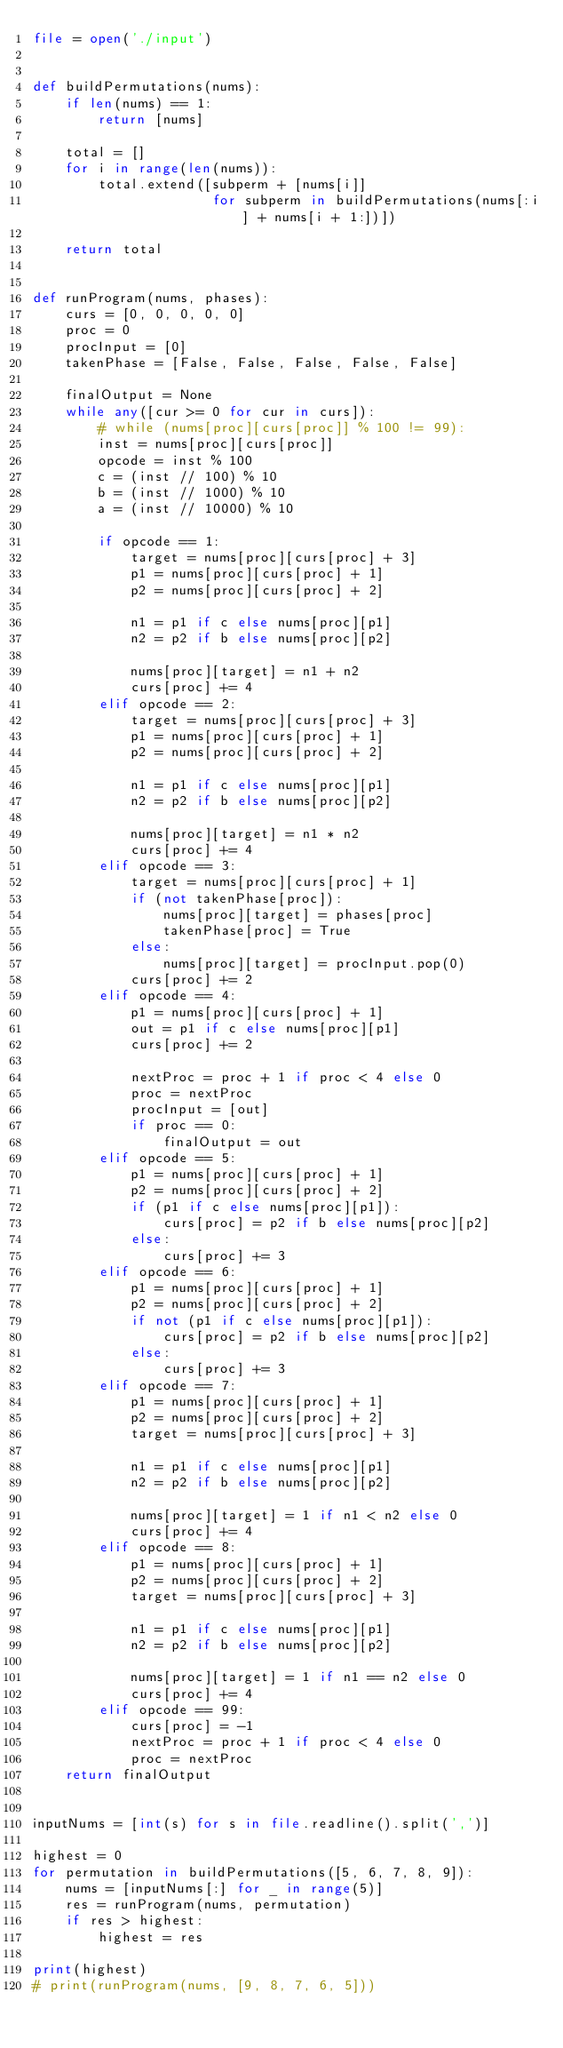<code> <loc_0><loc_0><loc_500><loc_500><_Python_>file = open('./input')


def buildPermutations(nums):
    if len(nums) == 1:
        return [nums]

    total = []
    for i in range(len(nums)):
        total.extend([subperm + [nums[i]]
                      for subperm in buildPermutations(nums[:i] + nums[i + 1:])])

    return total


def runProgram(nums, phases):
    curs = [0, 0, 0, 0, 0]
    proc = 0
    procInput = [0]
    takenPhase = [False, False, False, False, False]

    finalOutput = None
    while any([cur >= 0 for cur in curs]):
        # while (nums[proc][curs[proc]] % 100 != 99):
        inst = nums[proc][curs[proc]]
        opcode = inst % 100
        c = (inst // 100) % 10
        b = (inst // 1000) % 10
        a = (inst // 10000) % 10

        if opcode == 1:
            target = nums[proc][curs[proc] + 3]
            p1 = nums[proc][curs[proc] + 1]
            p2 = nums[proc][curs[proc] + 2]

            n1 = p1 if c else nums[proc][p1]
            n2 = p2 if b else nums[proc][p2]

            nums[proc][target] = n1 + n2
            curs[proc] += 4
        elif opcode == 2:
            target = nums[proc][curs[proc] + 3]
            p1 = nums[proc][curs[proc] + 1]
            p2 = nums[proc][curs[proc] + 2]

            n1 = p1 if c else nums[proc][p1]
            n2 = p2 if b else nums[proc][p2]

            nums[proc][target] = n1 * n2
            curs[proc] += 4
        elif opcode == 3:
            target = nums[proc][curs[proc] + 1]
            if (not takenPhase[proc]):
                nums[proc][target] = phases[proc]
                takenPhase[proc] = True
            else:
                nums[proc][target] = procInput.pop(0)
            curs[proc] += 2
        elif opcode == 4:
            p1 = nums[proc][curs[proc] + 1]
            out = p1 if c else nums[proc][p1]
            curs[proc] += 2

            nextProc = proc + 1 if proc < 4 else 0
            proc = nextProc
            procInput = [out]
            if proc == 0:
                finalOutput = out
        elif opcode == 5:
            p1 = nums[proc][curs[proc] + 1]
            p2 = nums[proc][curs[proc] + 2]
            if (p1 if c else nums[proc][p1]):
                curs[proc] = p2 if b else nums[proc][p2]
            else:
                curs[proc] += 3
        elif opcode == 6:
            p1 = nums[proc][curs[proc] + 1]
            p2 = nums[proc][curs[proc] + 2]
            if not (p1 if c else nums[proc][p1]):
                curs[proc] = p2 if b else nums[proc][p2]
            else:
                curs[proc] += 3
        elif opcode == 7:
            p1 = nums[proc][curs[proc] + 1]
            p2 = nums[proc][curs[proc] + 2]
            target = nums[proc][curs[proc] + 3]

            n1 = p1 if c else nums[proc][p1]
            n2 = p2 if b else nums[proc][p2]

            nums[proc][target] = 1 if n1 < n2 else 0
            curs[proc] += 4
        elif opcode == 8:
            p1 = nums[proc][curs[proc] + 1]
            p2 = nums[proc][curs[proc] + 2]
            target = nums[proc][curs[proc] + 3]

            n1 = p1 if c else nums[proc][p1]
            n2 = p2 if b else nums[proc][p2]

            nums[proc][target] = 1 if n1 == n2 else 0
            curs[proc] += 4
        elif opcode == 99:
            curs[proc] = -1
            nextProc = proc + 1 if proc < 4 else 0
            proc = nextProc
    return finalOutput


inputNums = [int(s) for s in file.readline().split(',')]

highest = 0
for permutation in buildPermutations([5, 6, 7, 8, 9]):
    nums = [inputNums[:] for _ in range(5)]
    res = runProgram(nums, permutation)
    if res > highest:
        highest = res

print(highest)
# print(runProgram(nums, [9, 8, 7, 6, 5]))
</code> 